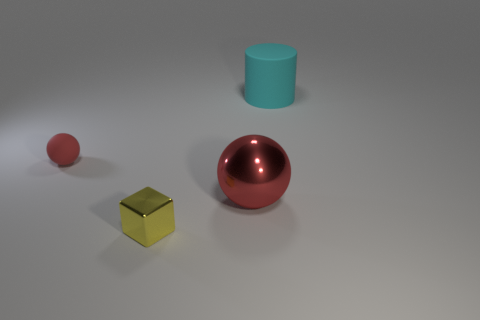Add 3 brown matte cubes. How many objects exist? 7 Subtract 1 blocks. How many blocks are left? 0 Subtract all blocks. How many objects are left? 3 Add 3 big cyan cylinders. How many big cyan cylinders are left? 4 Add 3 large purple rubber cylinders. How many large purple rubber cylinders exist? 3 Subtract 0 brown balls. How many objects are left? 4 Subtract all cyan blocks. Subtract all cyan balls. How many blocks are left? 1 Subtract all red blocks. How many red cylinders are left? 0 Subtract all small red spheres. Subtract all small objects. How many objects are left? 1 